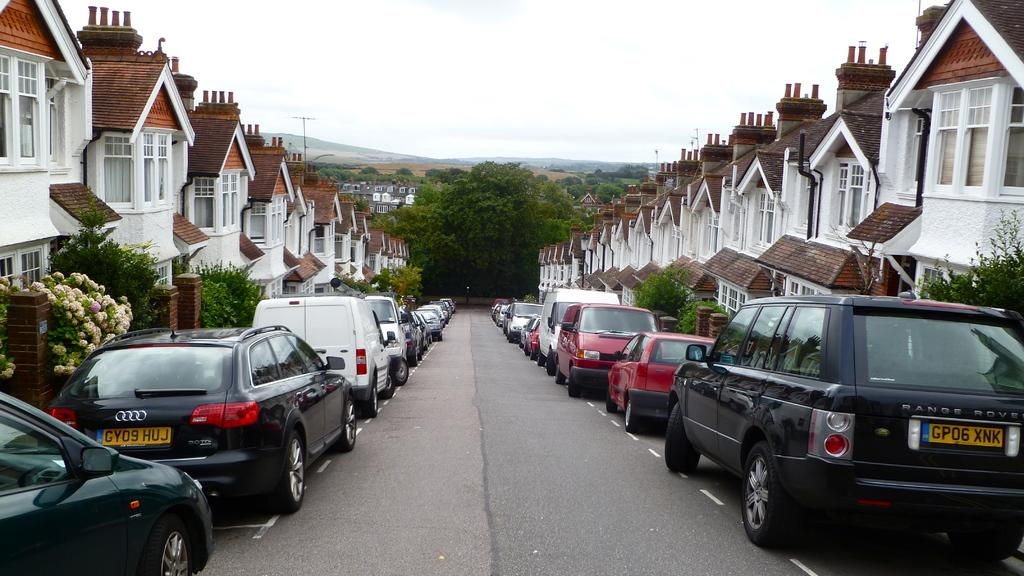What types of vehicles can be seen beside the road in the image? There are cars and vans parked beside the road in the image. What kind of structures are visible in the image? There are houses with windows in the image. What type of vegetation is present in the image? There are trees in the image. Can you describe any flora with flowers in the image? There is a plant with flowers in the image. What is the main pathway visible in the image? There is a road visible in the image. How many brothers are playing with the cows in the image? There are no cows or brothers present in the image. What is the plot of the story being told in the image? The image is not a story, so there is no plot to describe. 